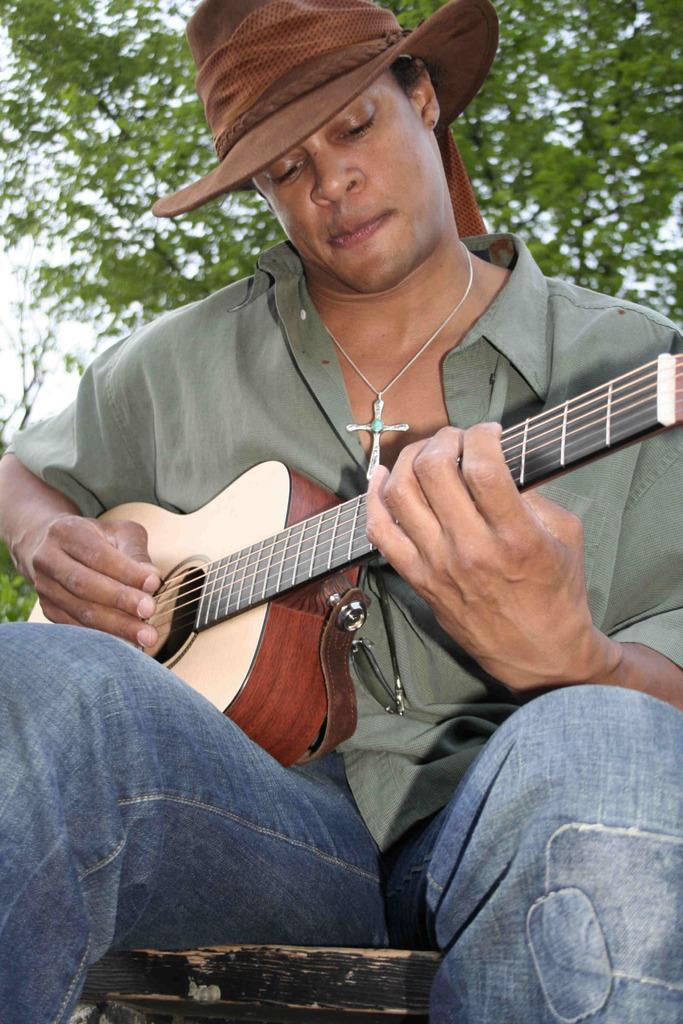What is the main subject of the image? There is a person in the image. What is the person wearing? The person is wearing a shirt and a hat. What accessory is the person wearing around their neck? The person has a cross on their neck. What is the person holding in the image? The person is holding a guitar. What is the person doing with the guitar? The person is playing the guitar. What can be seen in the background of the image? There is a tree in the background of the image. What team does the person support, as indicated by their shirt in the image? There is no information about a team or any team affiliation on the person's shirt in the image. How does the person's throat feel while playing the guitar in the image? There is no information about the person's throat or how they feel while playing the guitar in the image. 